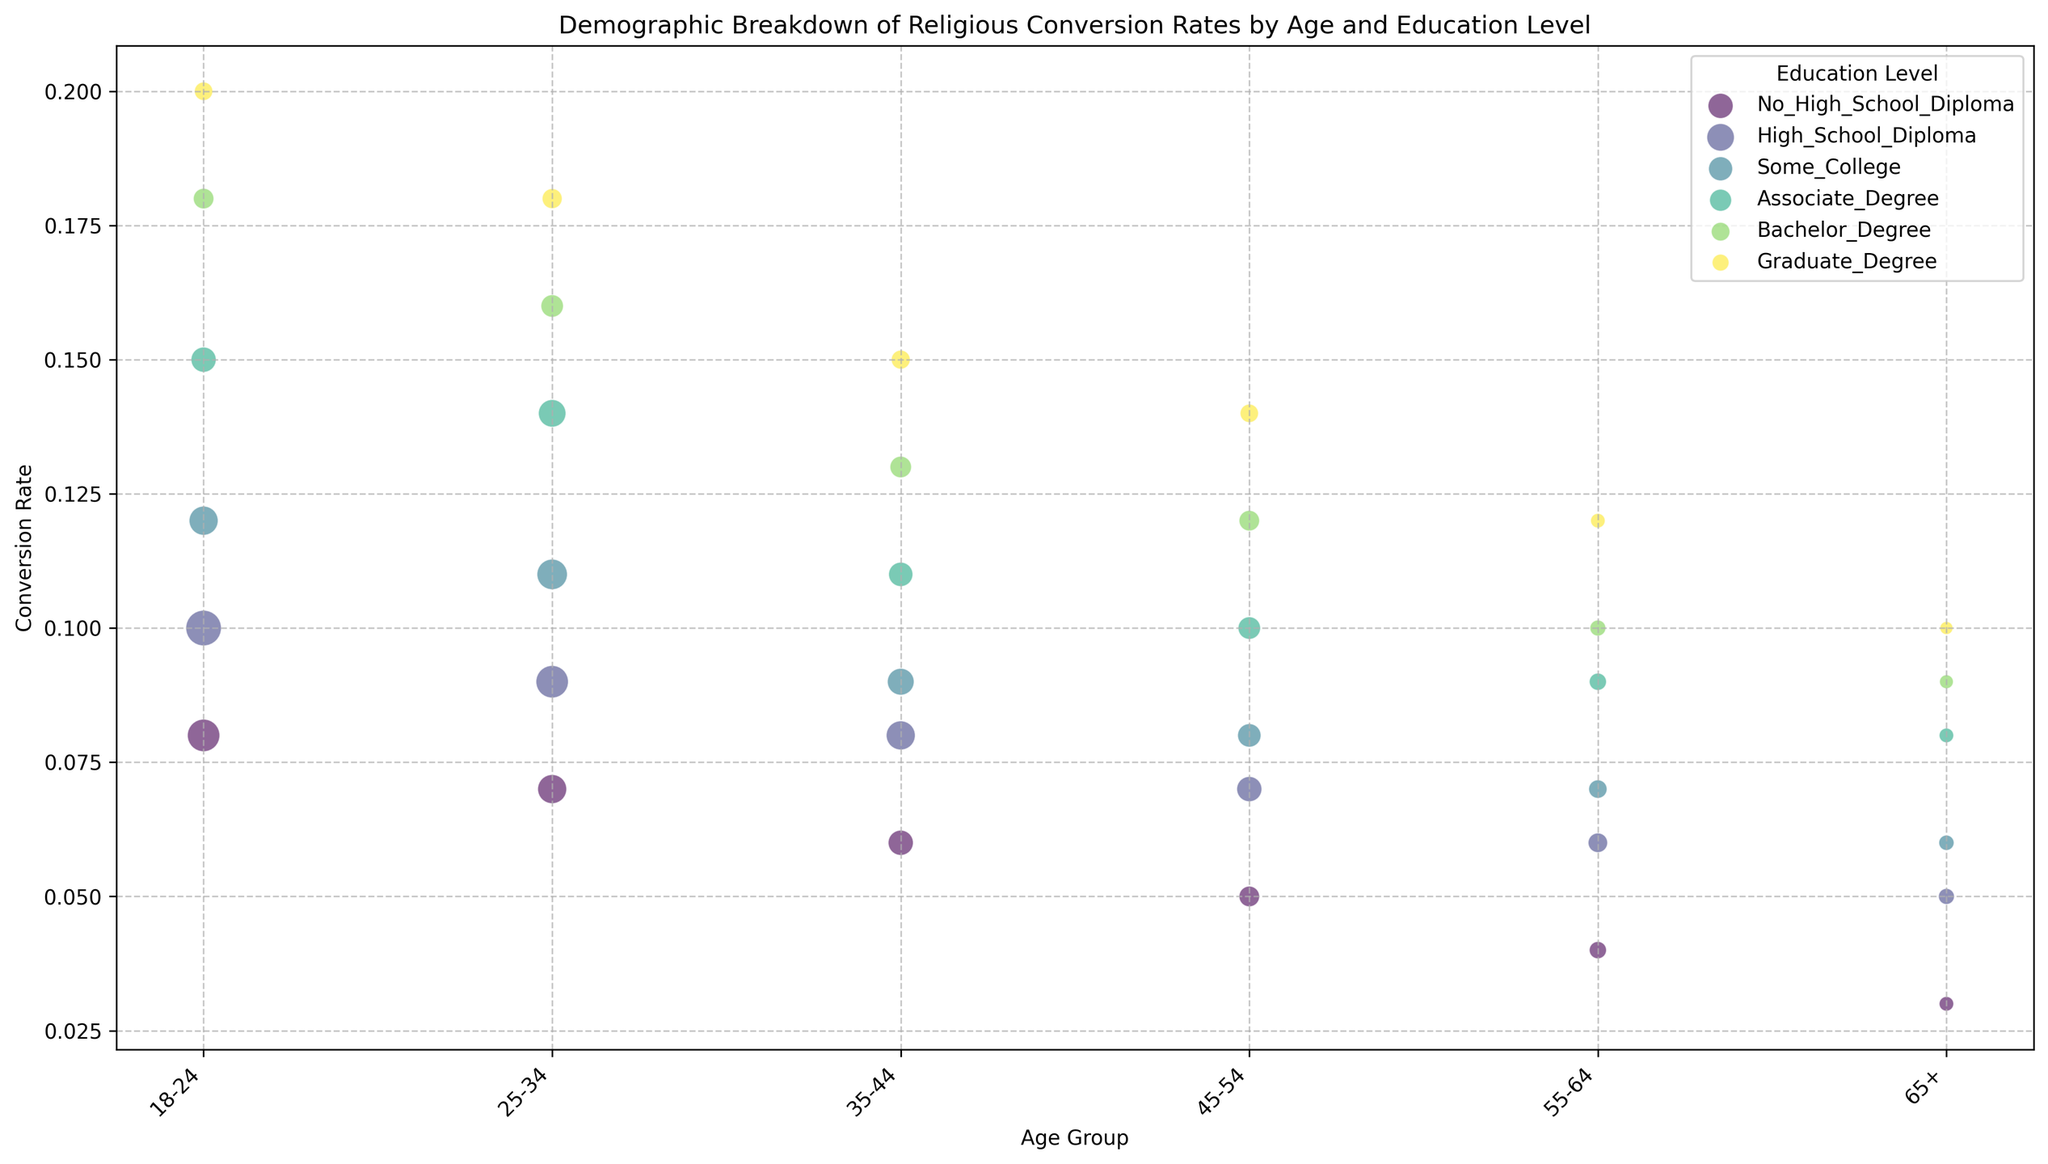Which education level has the highest conversion rate in the 18-24 age group? Look for the color representing each education level within the 18-24 age group and find the one with the highest y-axis value. The Graduate Degree group has the highest position in the 18-24 age group.
Answer: Graduate Degree How does the population size of individuals aged 25-34 with a High School Diploma compare to those aged 25-34 with Some College education? Identify the bubble sizes for individuals aged 25-34 with High School Diploma and Some College education levels. Compare the sizes visually. The High School Diploma bubble is larger than the Some College bubble.
Answer: Greater Which age group has the least variation in conversion rates across all education levels? Examine the vertical spread of bubbles for each age group to see which one has the least difference in y-values among all its education levels. The 65+ age group shows the least vertical spread.
Answer: 65+ For the 45-54 age group, what is the difference in conversion rates between those with a Bachelor's Degree and those with an Associate Degree? Find the y-axis values for the Bachelor's Degree and Associate Degree within the 45-54 age group and subtract the latter from the former. The difference is 0.12 - 0.10 = 0.02.
Answer: 0.02 What is the average conversion rate for individuals with an Associate Degree across all age groups? Identify the y-axis values for all Associate Degree bubbles, sum them up, and divide by the number of age groups (6). The rates are 0.15, 0.14, 0.11, 0.10, 0.09, and 0.08. The average is (0.15 + 0.14 + 0.11 + 0.10 + 0.09 + 0.08) / 6 = 0.1117.
Answer: 0.1117 Which education level shows the largest decrease in conversion rate as age increases from the 18-24 to the 65+ age group? Track the y-axis values for each education level from the 18-24 to the 65+ groups and find the largest drop. The Graduate Degree conversion rate drops from 0.20 to 0.10, a decrease of 0.10.
Answer: Graduate Degree In the 55-64 age group, which education level has the smallest bubble, and what does this represent? Look for the smallest bubble size within the 55-64 age group and identify the education level. The Graduate Degree has the smallest bubble, representing the smallest population size.
Answer: Graduate Degree How does the conversion rate trend change for individuals with a High School Diploma from the 18-24 to the 65+ age groups? Follow the trend line of bubbles for High School Diploma from the 18-24 to the 65+ age groups, noting the changes in the y-values. The conversion rate decreases consistently from 0.10 to 0.05.
Answer: Decreases Which two age groups have the most similar average conversion rates across all education levels, and what are those averages? Calculate the average conversion rate for each age group across all education levels, then compare to find the most similar ones. The averages are (0.12, 0.12, 0.10, 0.09, 0.08, 0.07), so 18-24 and 25-34, both with an average of 0.12.
Answer: 18-24, 25-34 What is the total population size for individuals aged 35-44 with no higher than a Bachelor's Degree? Sum the population sizes for 35-44 age group individuals with No High School Diploma, High School Diploma, Some College, Associate Degree, and Bachelor's Degree. Total is 15000 + 20000 + 17000 + 14000 + 11000 = 77000.
Answer: 77000 